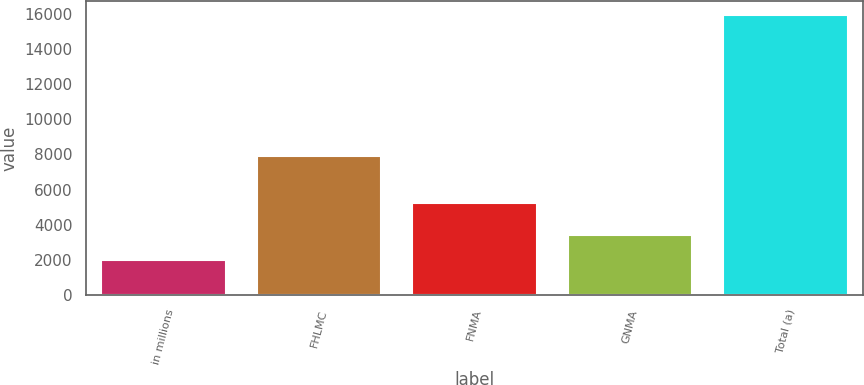Convert chart to OTSL. <chart><loc_0><loc_0><loc_500><loc_500><bar_chart><fcel>in millions<fcel>FHLMC<fcel>FNMA<fcel>GNMA<fcel>Total (a)<nl><fcel>2012<fcel>7923<fcel>5246<fcel>3402.3<fcel>15915<nl></chart> 